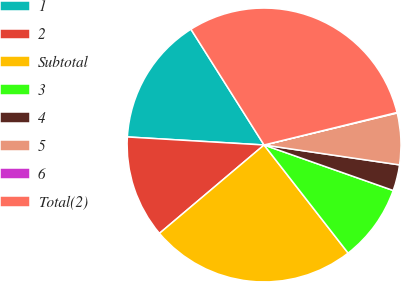Convert chart to OTSL. <chart><loc_0><loc_0><loc_500><loc_500><pie_chart><fcel>1<fcel>2<fcel>Subtotal<fcel>3<fcel>4<fcel>5<fcel>6<fcel>Total(2)<nl><fcel>15.1%<fcel>12.1%<fcel>24.36%<fcel>9.09%<fcel>3.07%<fcel>6.08%<fcel>0.06%<fcel>30.15%<nl></chart> 